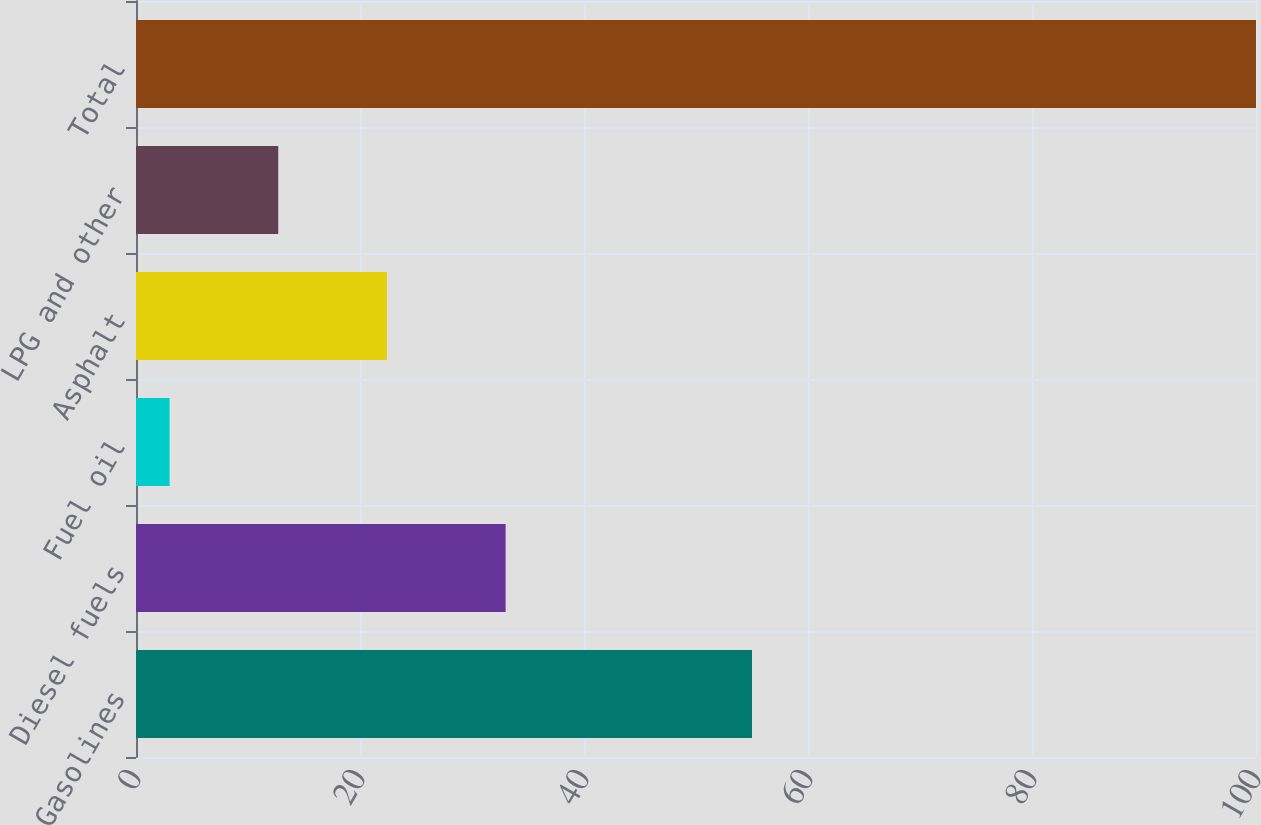Convert chart. <chart><loc_0><loc_0><loc_500><loc_500><bar_chart><fcel>Gasolines<fcel>Diesel fuels<fcel>Fuel oil<fcel>Asphalt<fcel>LPG and other<fcel>Total<nl><fcel>55<fcel>33<fcel>3<fcel>22.4<fcel>12.7<fcel>100<nl></chart> 